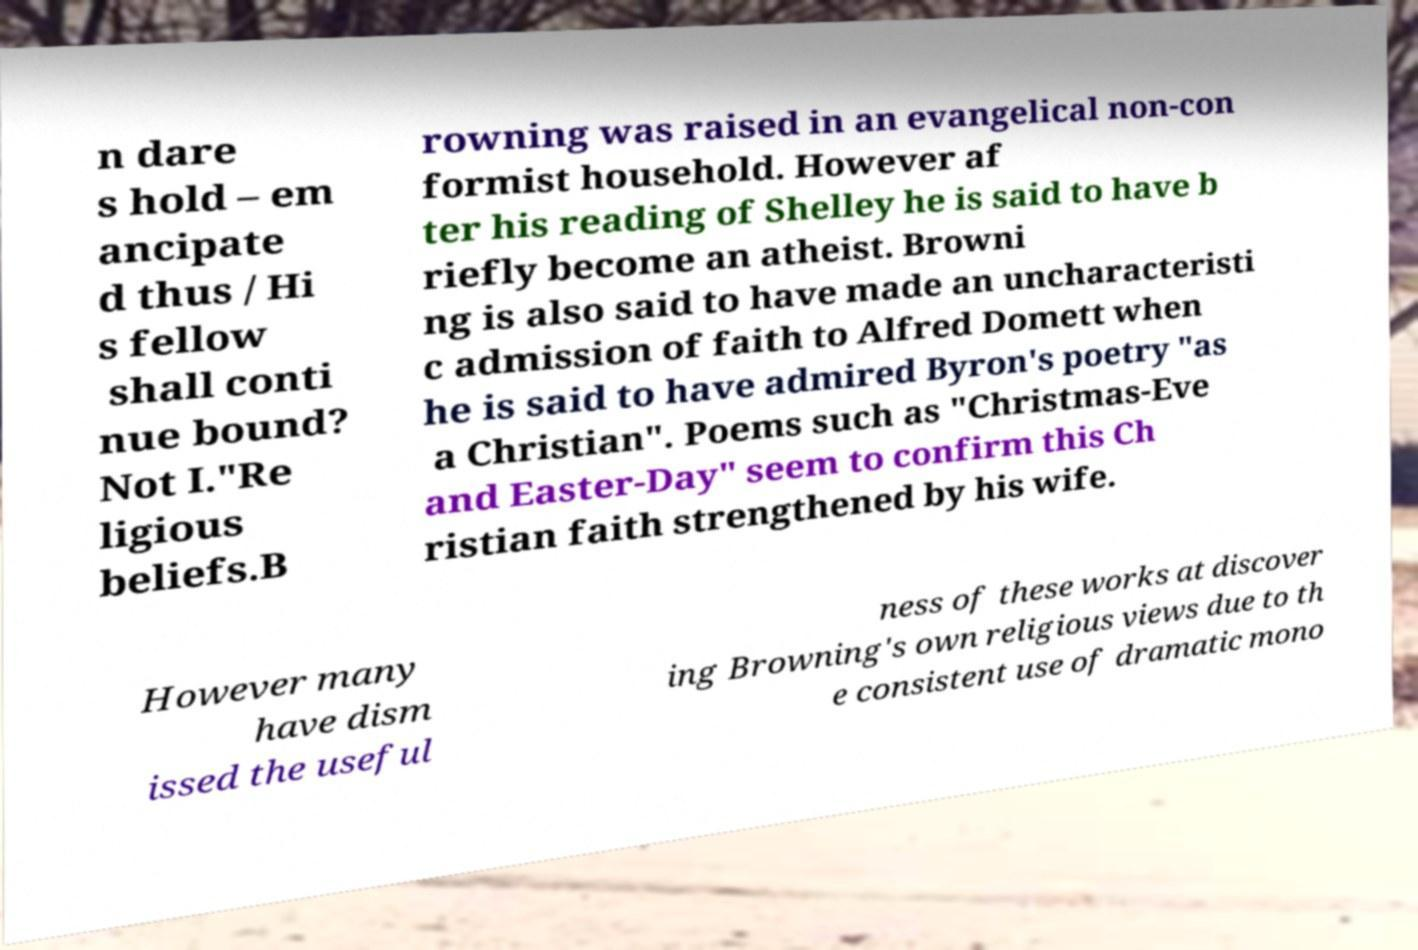What messages or text are displayed in this image? I need them in a readable, typed format. n dare s hold – em ancipate d thus / Hi s fellow shall conti nue bound? Not I."Re ligious beliefs.B rowning was raised in an evangelical non-con formist household. However af ter his reading of Shelley he is said to have b riefly become an atheist. Browni ng is also said to have made an uncharacteristi c admission of faith to Alfred Domett when he is said to have admired Byron's poetry "as a Christian". Poems such as "Christmas-Eve and Easter-Day" seem to confirm this Ch ristian faith strengthened by his wife. However many have dism issed the useful ness of these works at discover ing Browning's own religious views due to th e consistent use of dramatic mono 